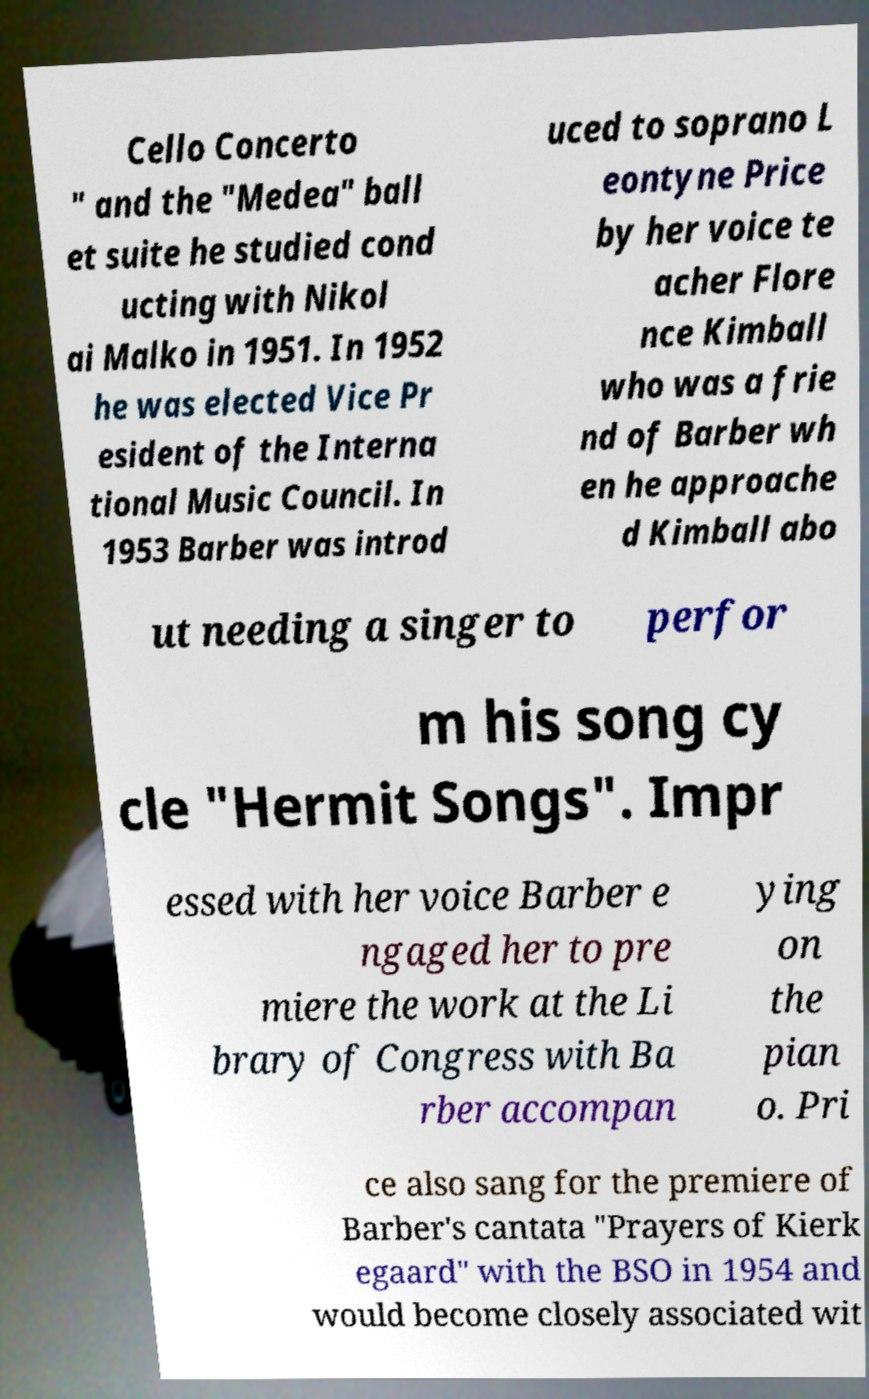Can you accurately transcribe the text from the provided image for me? Cello Concerto " and the "Medea" ball et suite he studied cond ucting with Nikol ai Malko in 1951. In 1952 he was elected Vice Pr esident of the Interna tional Music Council. In 1953 Barber was introd uced to soprano L eontyne Price by her voice te acher Flore nce Kimball who was a frie nd of Barber wh en he approache d Kimball abo ut needing a singer to perfor m his song cy cle "Hermit Songs". Impr essed with her voice Barber e ngaged her to pre miere the work at the Li brary of Congress with Ba rber accompan ying on the pian o. Pri ce also sang for the premiere of Barber's cantata "Prayers of Kierk egaard" with the BSO in 1954 and would become closely associated wit 